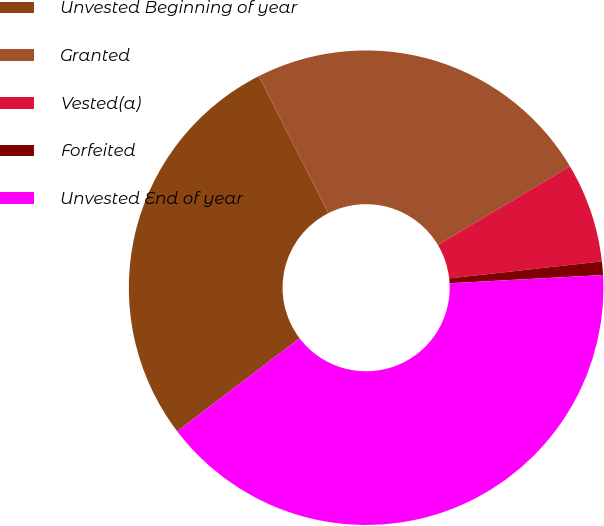Convert chart to OTSL. <chart><loc_0><loc_0><loc_500><loc_500><pie_chart><fcel>Unvested Beginning of year<fcel>Granted<fcel>Vested(a)<fcel>Forfeited<fcel>Unvested End of year<nl><fcel>27.87%<fcel>23.92%<fcel>6.78%<fcel>0.92%<fcel>40.51%<nl></chart> 